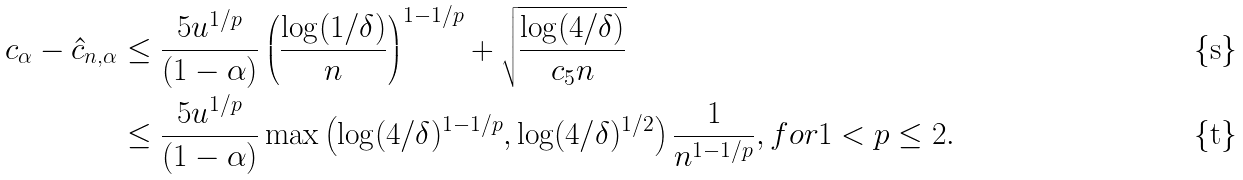Convert formula to latex. <formula><loc_0><loc_0><loc_500><loc_500>c _ { \alpha } - \hat { c } _ { n , \alpha } & \leq \frac { 5 u ^ { 1 / p } } { ( 1 - \alpha ) } \left ( \frac { \log ( 1 / \delta ) } { n } \right ) ^ { 1 - 1 / p } + \sqrt { \frac { \log ( 4 / \delta ) } { c _ { 5 } n } } \\ & \leq \frac { 5 u ^ { 1 / p } } { ( 1 - \alpha ) } \max \left ( \log ( 4 / \delta ) ^ { 1 - 1 / p } , \log ( 4 / \delta ) ^ { 1 / 2 } \right ) \frac { 1 } { n ^ { 1 - 1 / p } } , f o r 1 < p \leq 2 .</formula> 